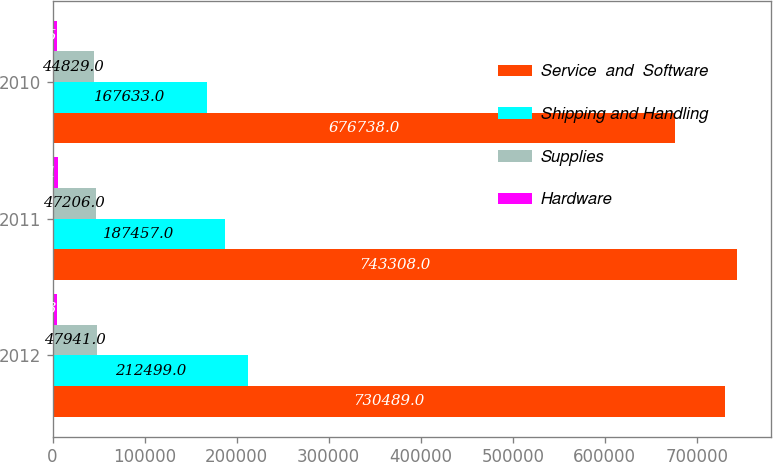Convert chart to OTSL. <chart><loc_0><loc_0><loc_500><loc_500><stacked_bar_chart><ecel><fcel>2012<fcel>2011<fcel>2010<nl><fcel>Service  and  Software<fcel>730489<fcel>743308<fcel>676738<nl><fcel>Shipping and Handling<fcel>212499<fcel>187457<fcel>167633<nl><fcel>Supplies<fcel>47941<fcel>47206<fcel>44829<nl><fcel>Hardware<fcel>5239<fcel>5517<fcel>5159<nl></chart> 